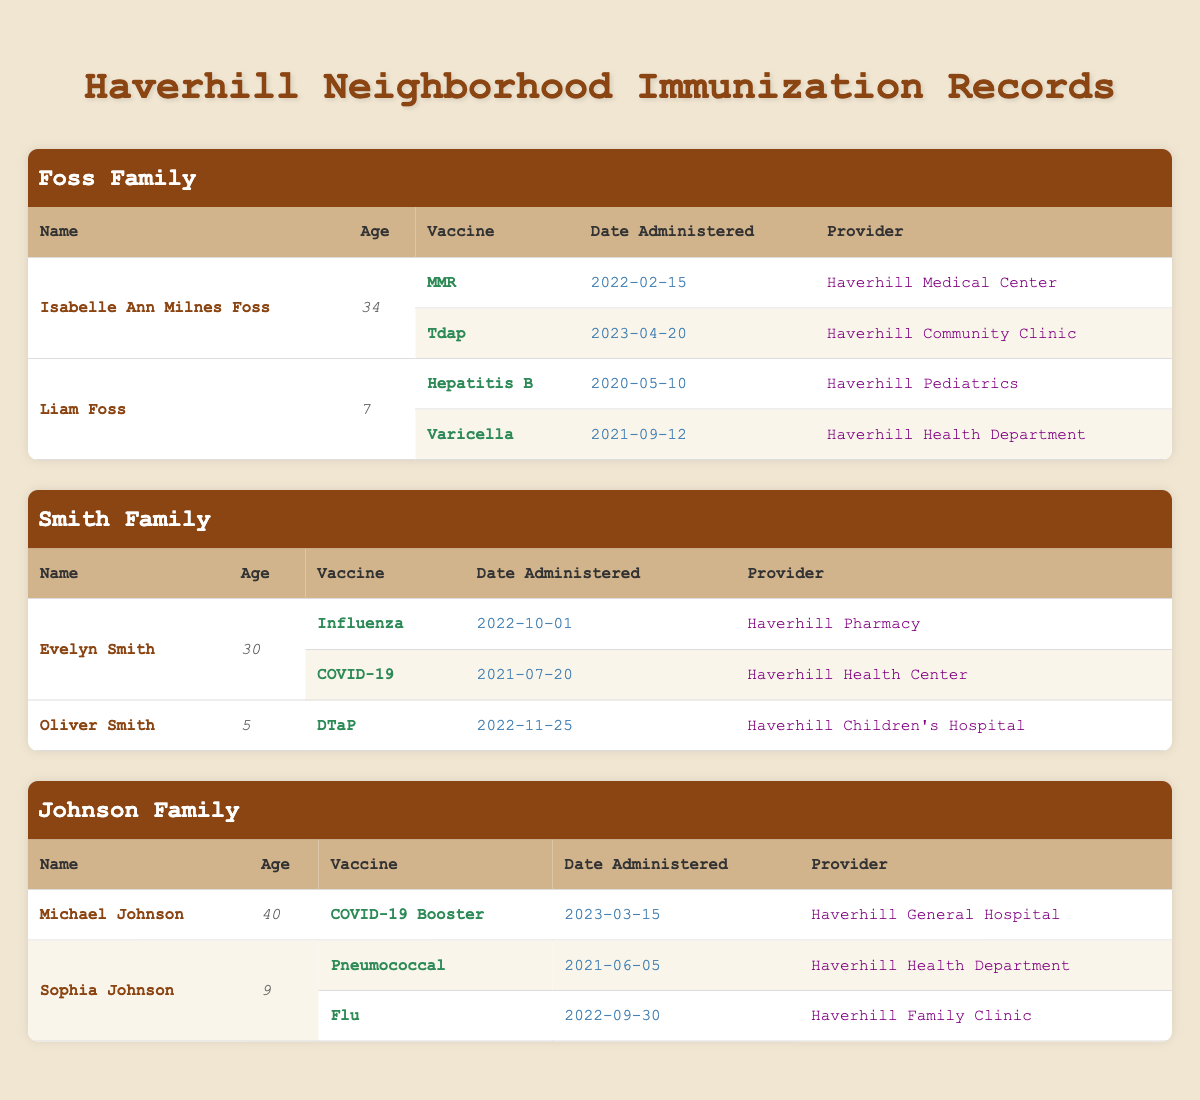What immunizations did Isabelle Ann Milnes Foss receive? Isabelle Ann Milnes Foss received two immunizations: MMR on February 15, 2022, and Tdap on April 20, 2023. This information is found in her corresponding row entries in the table under the Foss family section.
Answer: MMR and Tdap How many vaccines did Liam Foss receive? Liam Foss received two vaccines: Hepatitis B and Varicella. Each of these is listed separately in his row entries under the Foss family section of the table.
Answer: Two Did Evelyn Smith receive the COVID-19 vaccine? Yes, Evelyn Smith did receive the COVID-19 vaccine on July 20, 2021. This is indicated in her immunization records listed in the Smith family section.
Answer: Yes Which family member received the Pneumococcal vaccine and when? Sophia Johnson received the Pneumococcal vaccine on June 5, 2021. This detail is found in her row entry within the Johnson family section of the table.
Answer: Sophia Johnson on June 5, 2021 What is the average age of the family members listed in the Johnson family? The ages of the members in the Johnson family are 40 for Michael Johnson and 9 for Sophia Johnson, which adds up to 49. Then, to find the average, we divide by the number of family members, which is 2: 49/2 = 24.5.
Answer: 24.5 How many different providers administered vaccines to family members under 10 years old? The providers for the family members under 10 are Haverhill Pediatrics (Liam's Hepatitis B), Haverhill Health Department (Liam's Varicella), Haverhill Children's Hospital (Oliver's DTaP), and Haverhill Health Department (Sophia's Pneumococcal). That totals four unique providers: Haverhill Pediatrics, Haverhill Health Department, Haverhill Children's Hospital, and Haverhill Family Clinic.
Answer: Four Did any family receive vaccinations at Haverhill General Hospital? Yes, Michael Johnson received a COVID-19 Booster at Haverhill General Hospital, as noted in the Johnson family's entries in the table.
Answer: Yes Which vaccine was administered to Oliver Smith and when? Oliver Smith was administered the DTaP vaccine on November 25, 2022, as indicated in his row under the Smith family section.
Answer: DTaP on November 25, 2022 What is the most recent immunization date recorded for any family member? The most recent immunization date is April 20, 2023, for Isabelle Ann Milnes Foss’s Tdap vaccine. This is determined by comparing all the dates in the table.
Answer: April 20, 2023 